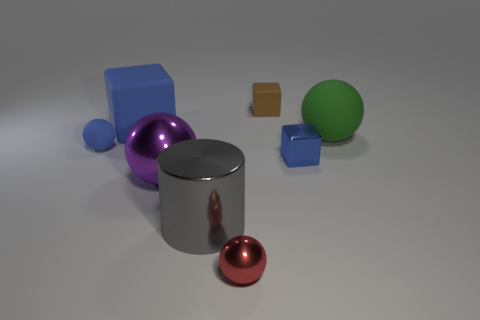Subtract all blue cubes. How many cubes are left? 1 Add 2 big green objects. How many objects exist? 10 Subtract 3 spheres. How many spheres are left? 1 Subtract all red spheres. How many spheres are left? 3 Subtract all purple cubes. How many purple spheres are left? 1 Add 1 gray objects. How many gray objects exist? 2 Subtract 0 red cubes. How many objects are left? 8 Subtract all cylinders. How many objects are left? 7 Subtract all blue cubes. Subtract all cyan cylinders. How many cubes are left? 1 Subtract all blue blocks. Subtract all tiny blue cubes. How many objects are left? 5 